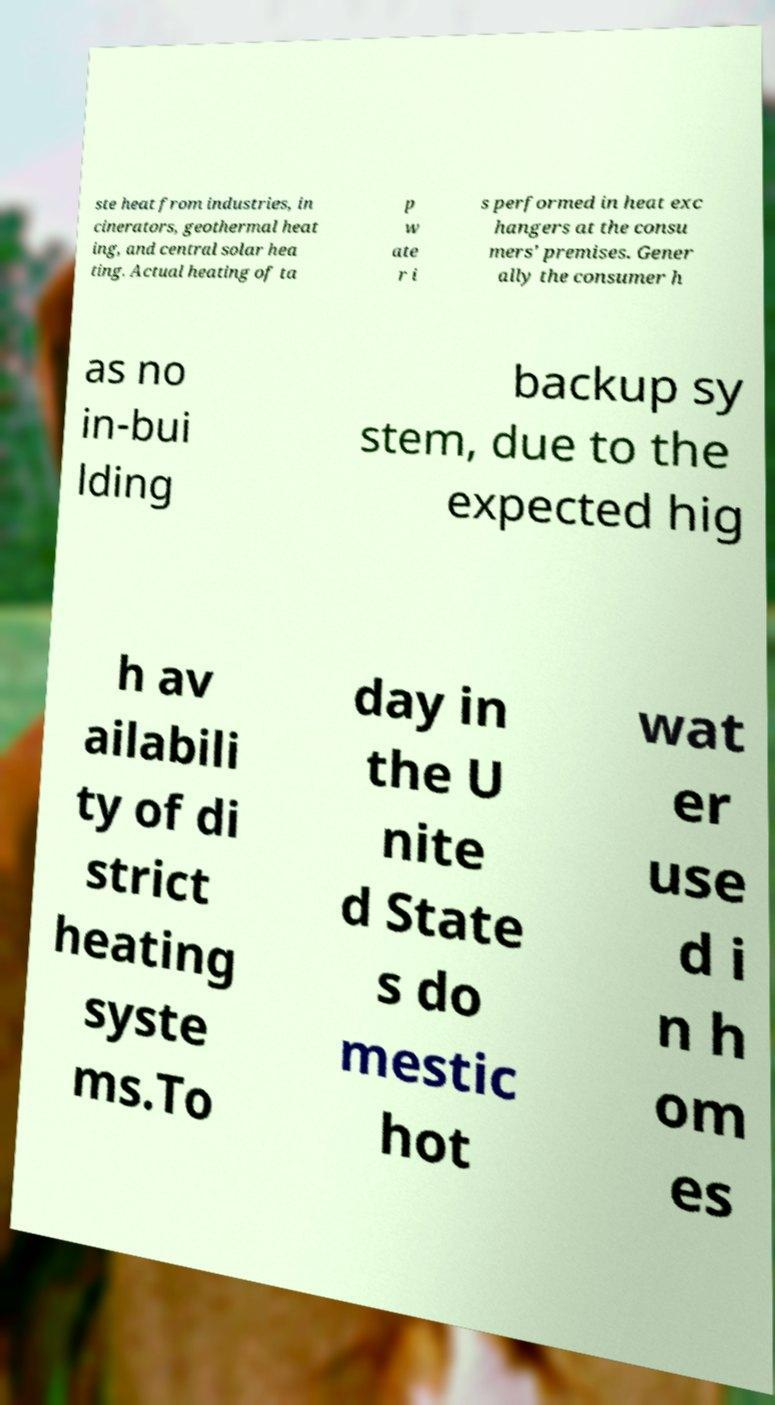What messages or text are displayed in this image? I need them in a readable, typed format. ste heat from industries, in cinerators, geothermal heat ing, and central solar hea ting. Actual heating of ta p w ate r i s performed in heat exc hangers at the consu mers' premises. Gener ally the consumer h as no in-bui lding backup sy stem, due to the expected hig h av ailabili ty of di strict heating syste ms.To day in the U nite d State s do mestic hot wat er use d i n h om es 